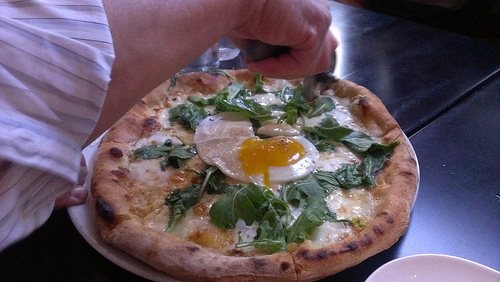Which kind of vegetable is the egg on? The egg is on top of spinach. 